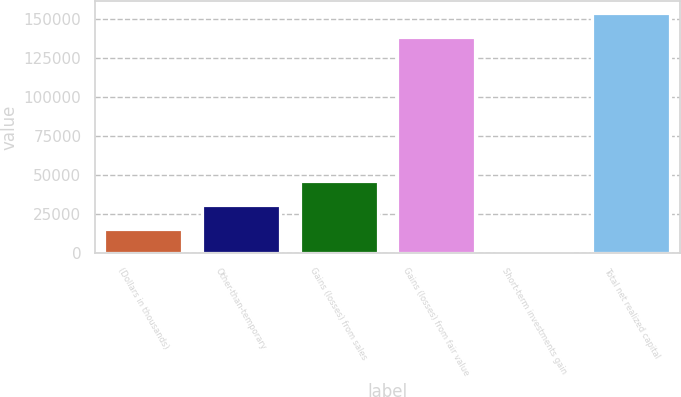<chart> <loc_0><loc_0><loc_500><loc_500><bar_chart><fcel>(Dollars in thousands)<fcel>Other-than-temporary<fcel>Gains (losses) from sales<fcel>Gains (losses) from fair value<fcel>Short-term investments gain<fcel>Total net realized capital<nl><fcel>15324.8<fcel>30643.6<fcel>45962.4<fcel>138973<fcel>6<fcel>154292<nl></chart> 